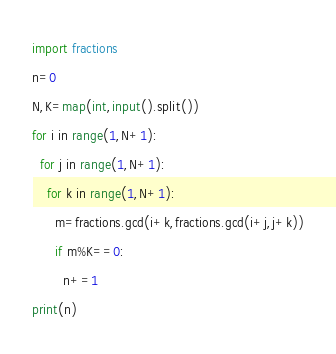<code> <loc_0><loc_0><loc_500><loc_500><_Python_>import fractions
n=0
N,K=map(int,input().split())
for i in range(1,N+1):
  for j in range(1,N+1):
    for k in range(1,N+1):
      m=fractions.gcd(i+k,fractions.gcd(i+j,j+k))
      if m%K==0:
        n+=1
print(n)</code> 